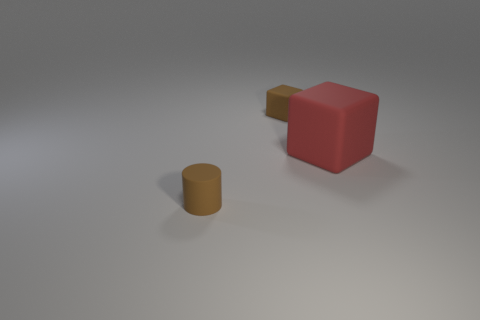What is the shape of the object that is the same color as the cylinder?
Your answer should be very brief. Cube. Does the matte cylinder have the same size as the matte cube in front of the tiny rubber block?
Provide a succinct answer. No. There is a object right of the small thing to the right of the tiny matte cylinder in front of the large object; what shape is it?
Your answer should be compact. Cube. Are there fewer red matte cubes than big brown metal cubes?
Provide a short and direct response. No. Are there any small objects on the left side of the big cube?
Your response must be concise. Yes. What shape is the rubber thing that is right of the tiny matte cylinder and to the left of the large red block?
Your answer should be very brief. Cube. Are there any other large red things of the same shape as the red matte object?
Make the answer very short. No. Do the brown matte object that is on the right side of the cylinder and the block in front of the small block have the same size?
Offer a terse response. No. Are there more cylinders than small spheres?
Your answer should be very brief. Yes. How many tiny things have the same material as the large red thing?
Provide a succinct answer. 2. 